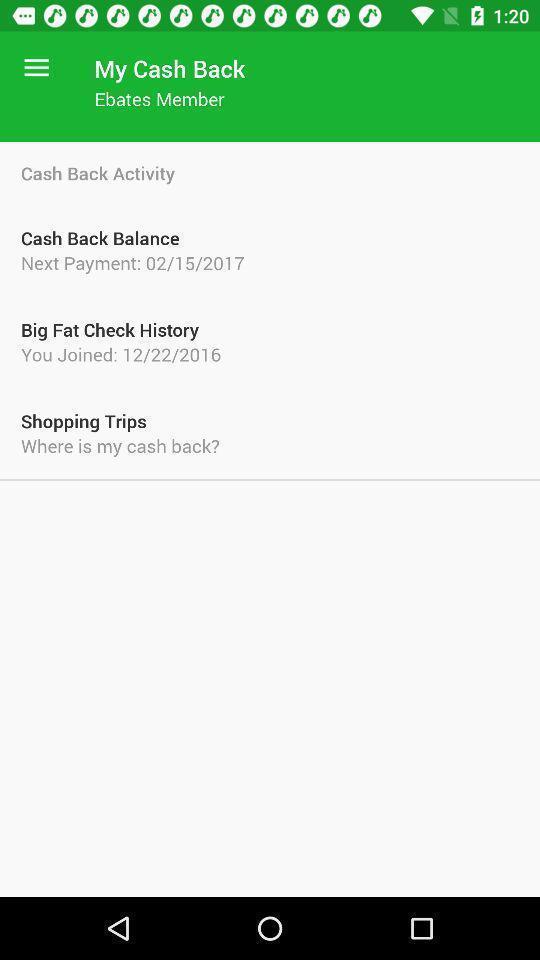Give me a narrative description of this picture. Page showing different information about application. 